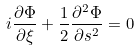Convert formula to latex. <formula><loc_0><loc_0><loc_500><loc_500>i \frac { \partial \Phi } { \partial \xi } + \frac { 1 } { 2 } \frac { \partial ^ { 2 } \Phi } { \partial s ^ { 2 } } = 0</formula> 